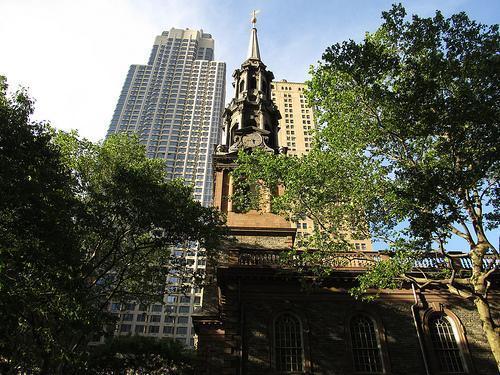How many clocks are in the photo?
Give a very brief answer. 1. How many buildings are in the photo?
Give a very brief answer. 3. How many buildings are one story high?
Give a very brief answer. 1. 